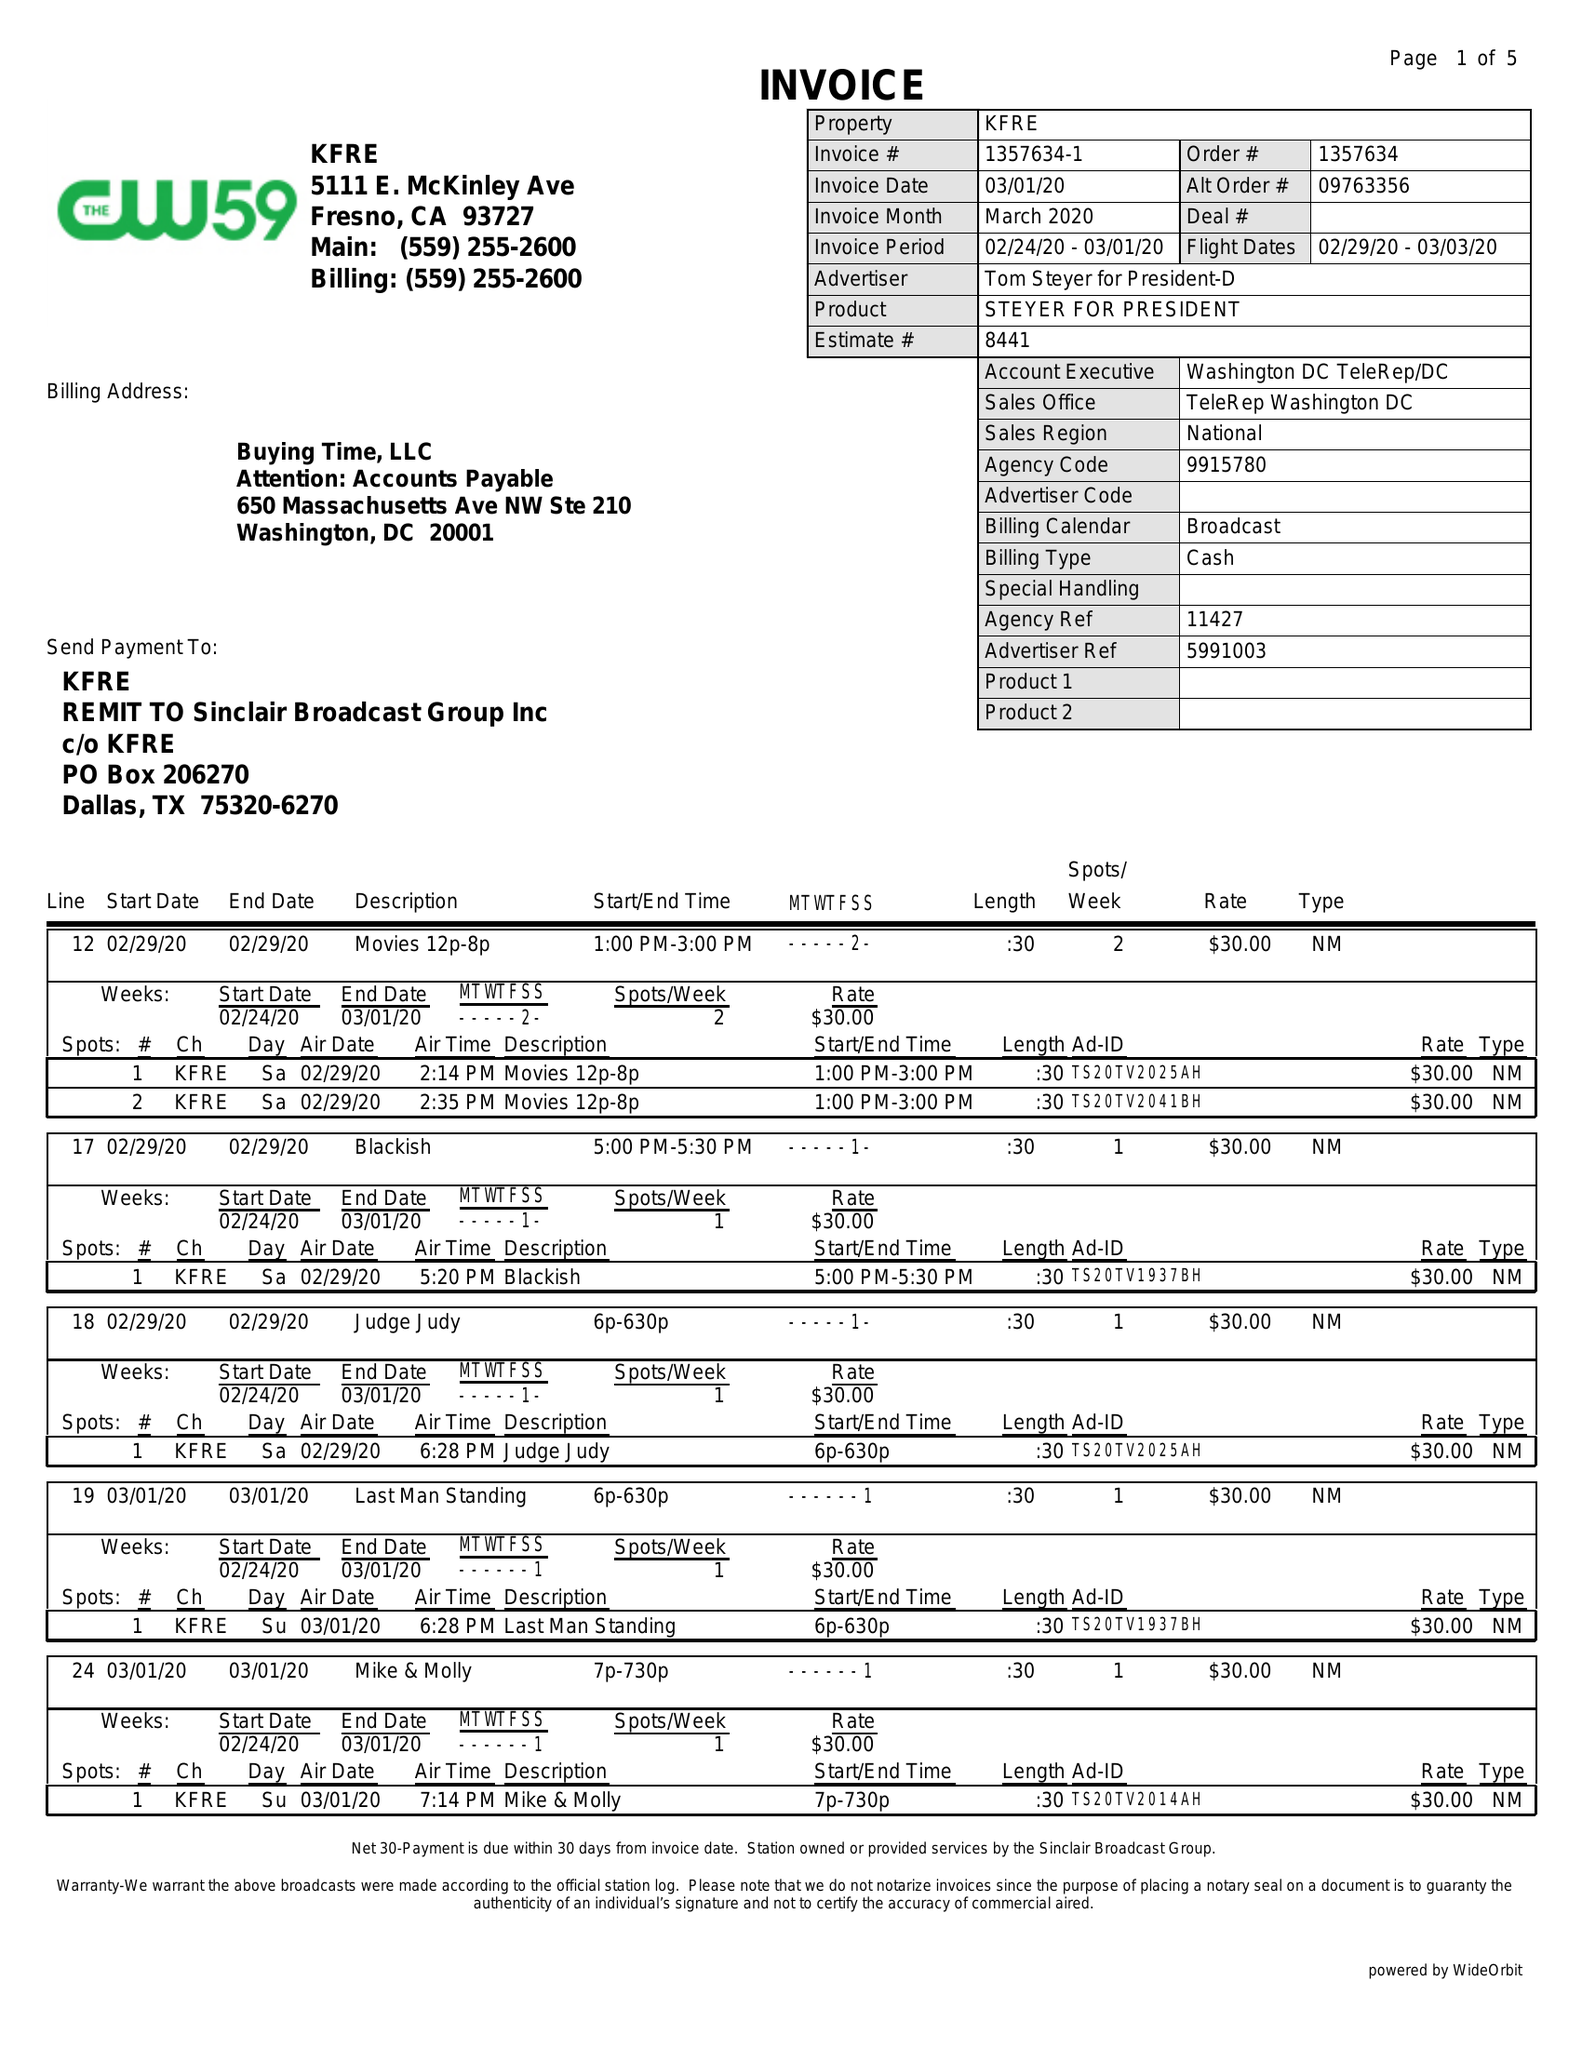What is the value for the advertiser?
Answer the question using a single word or phrase. TOM STEYER FOR PRESIDENT-D 